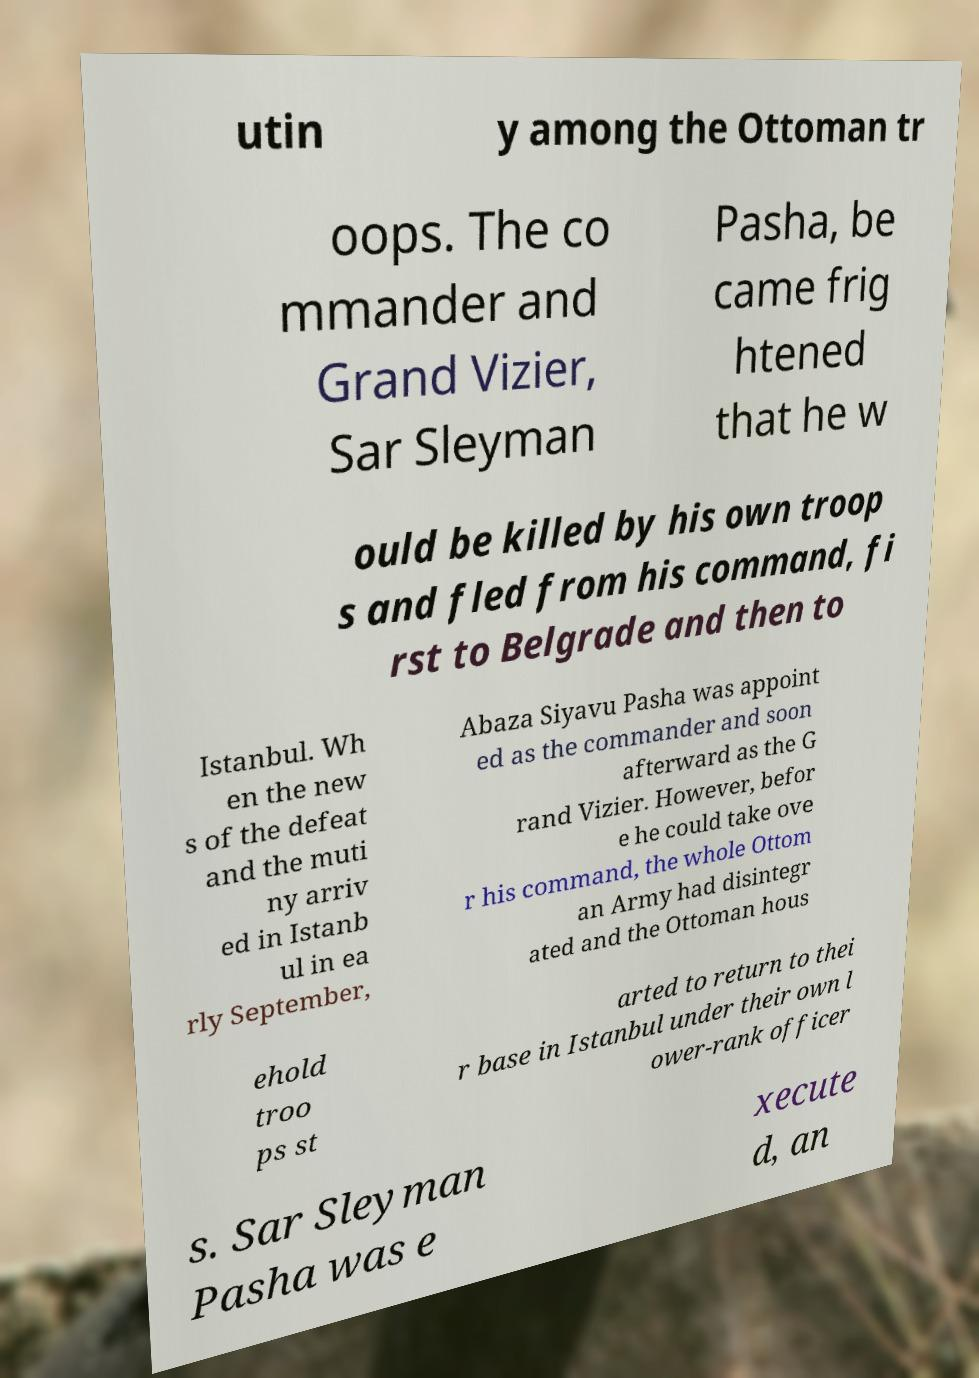Could you assist in decoding the text presented in this image and type it out clearly? utin y among the Ottoman tr oops. The co mmander and Grand Vizier, Sar Sleyman Pasha, be came frig htened that he w ould be killed by his own troop s and fled from his command, fi rst to Belgrade and then to Istanbul. Wh en the new s of the defeat and the muti ny arriv ed in Istanb ul in ea rly September, Abaza Siyavu Pasha was appoint ed as the commander and soon afterward as the G rand Vizier. However, befor e he could take ove r his command, the whole Ottom an Army had disintegr ated and the Ottoman hous ehold troo ps st arted to return to thei r base in Istanbul under their own l ower-rank officer s. Sar Sleyman Pasha was e xecute d, an 